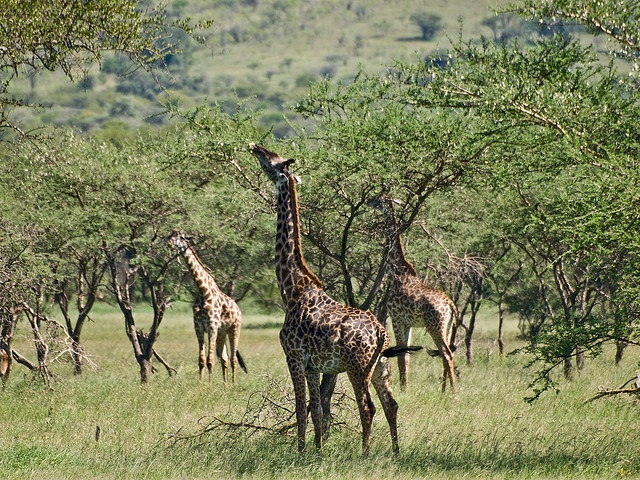Describe the objects in this image and their specific colors. I can see giraffe in darkgreen, black, and gray tones, giraffe in darkgreen, black, gray, and tan tones, and giraffe in darkgreen, black, tan, and ivory tones in this image. 